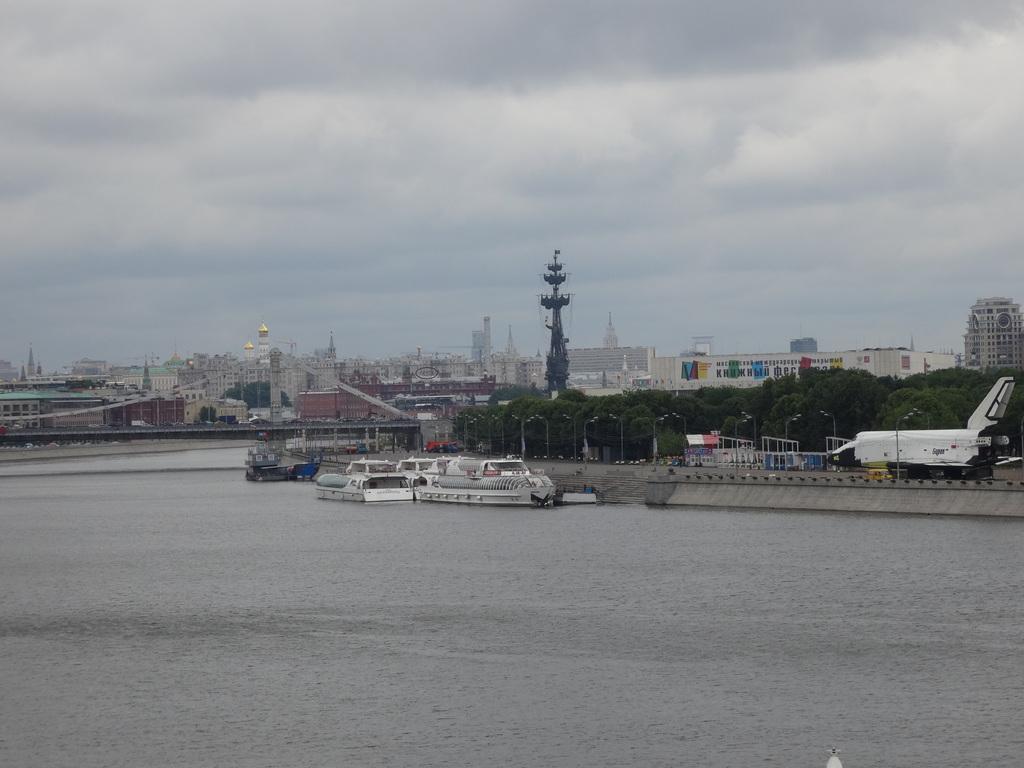In one or two sentences, can you explain what this image depicts? In this picture I can see boats in the water and I can see buildings, few trees and I can see few pole lights and a cloudy sky. 